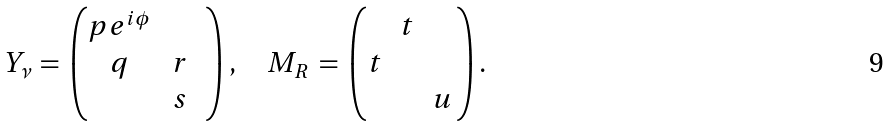<formula> <loc_0><loc_0><loc_500><loc_500>Y _ { \nu } \, = \, \begin{pmatrix} p e ^ { i \phi } & & \\ q & \, r & \\ & \, s & \end{pmatrix} , \quad M _ { R } \, = \, \begin{pmatrix} & t & \\ t & & \\ & & u \, \end{pmatrix} .</formula> 